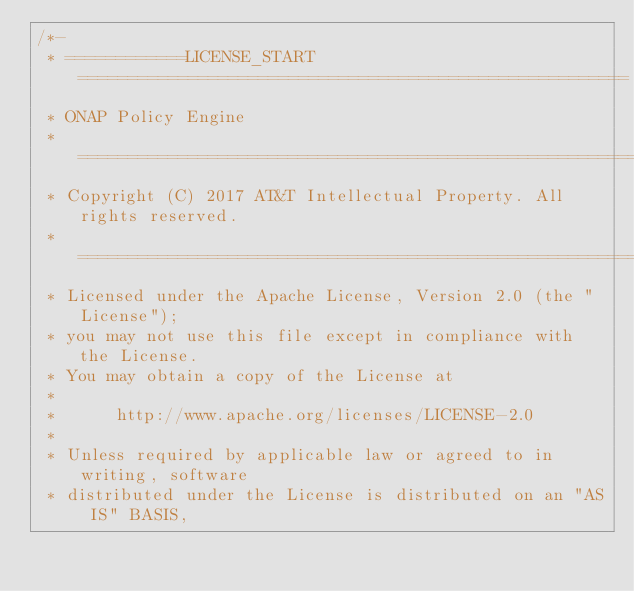Convert code to text. <code><loc_0><loc_0><loc_500><loc_500><_Java_>/*-
 * ============LICENSE_START=======================================================
 * ONAP Policy Engine
 * ================================================================================
 * Copyright (C) 2017 AT&T Intellectual Property. All rights reserved.
 * ================================================================================
 * Licensed under the Apache License, Version 2.0 (the "License");
 * you may not use this file except in compliance with the License.
 * You may obtain a copy of the License at
 * 
 *      http://www.apache.org/licenses/LICENSE-2.0
 * 
 * Unless required by applicable law or agreed to in writing, software
 * distributed under the License is distributed on an "AS IS" BASIS,</code> 